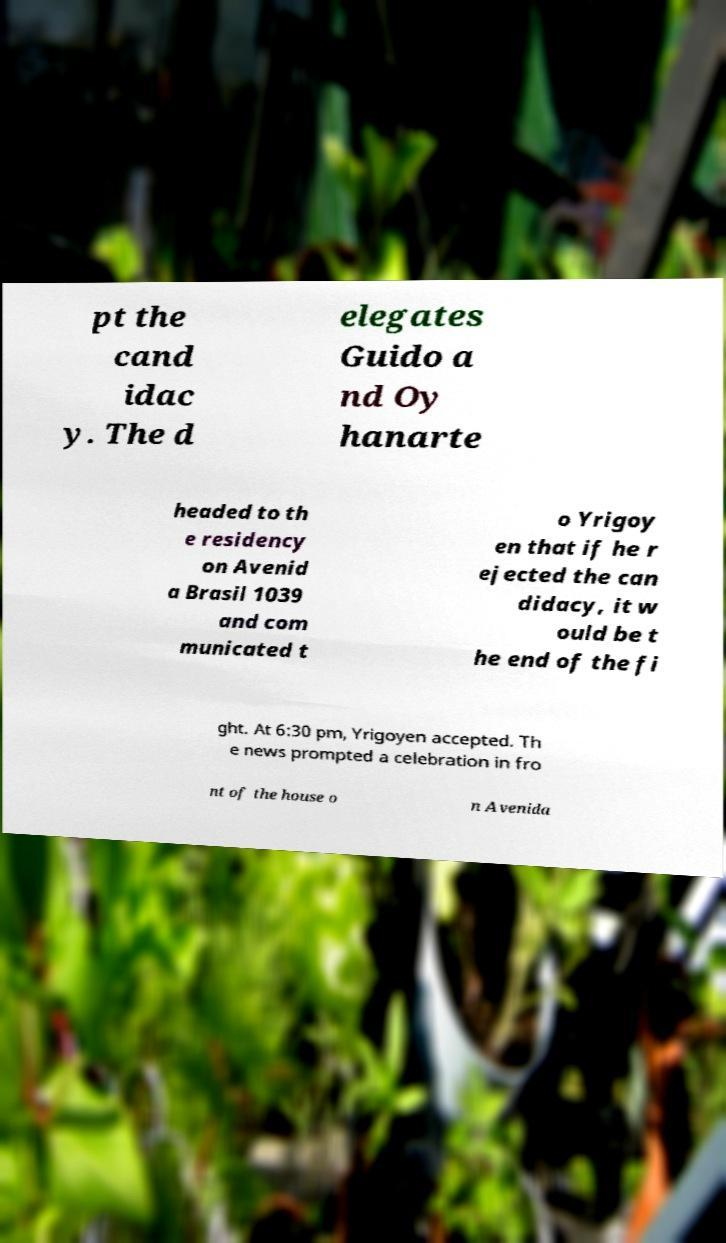Could you extract and type out the text from this image? pt the cand idac y. The d elegates Guido a nd Oy hanarte headed to th e residency on Avenid a Brasil 1039 and com municated t o Yrigoy en that if he r ejected the can didacy, it w ould be t he end of the fi ght. At 6:30 pm, Yrigoyen accepted. Th e news prompted a celebration in fro nt of the house o n Avenida 